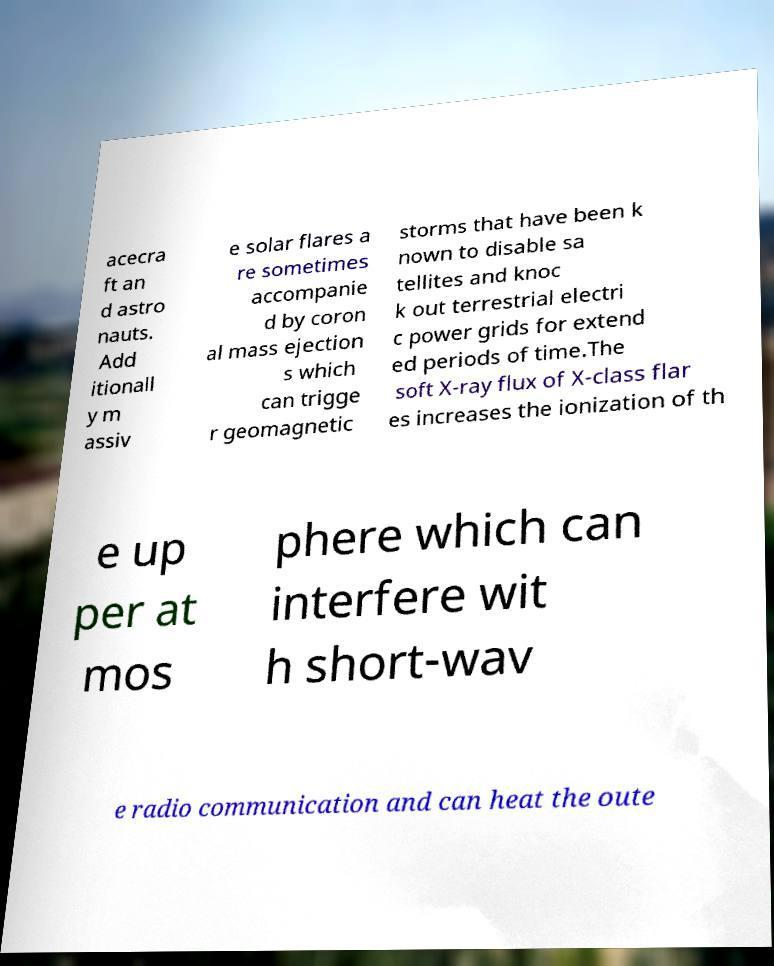There's text embedded in this image that I need extracted. Can you transcribe it verbatim? acecra ft an d astro nauts. Add itionall y m assiv e solar flares a re sometimes accompanie d by coron al mass ejection s which can trigge r geomagnetic storms that have been k nown to disable sa tellites and knoc k out terrestrial electri c power grids for extend ed periods of time.The soft X-ray flux of X-class flar es increases the ionization of th e up per at mos phere which can interfere wit h short-wav e radio communication and can heat the oute 